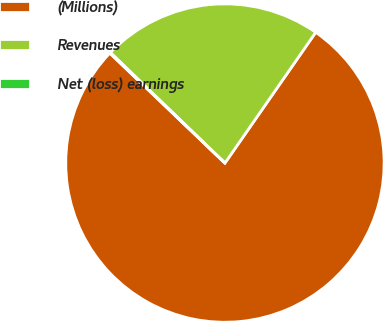Convert chart. <chart><loc_0><loc_0><loc_500><loc_500><pie_chart><fcel>(Millions)<fcel>Revenues<fcel>Net (loss) earnings<nl><fcel>77.48%<fcel>22.45%<fcel>0.08%<nl></chart> 